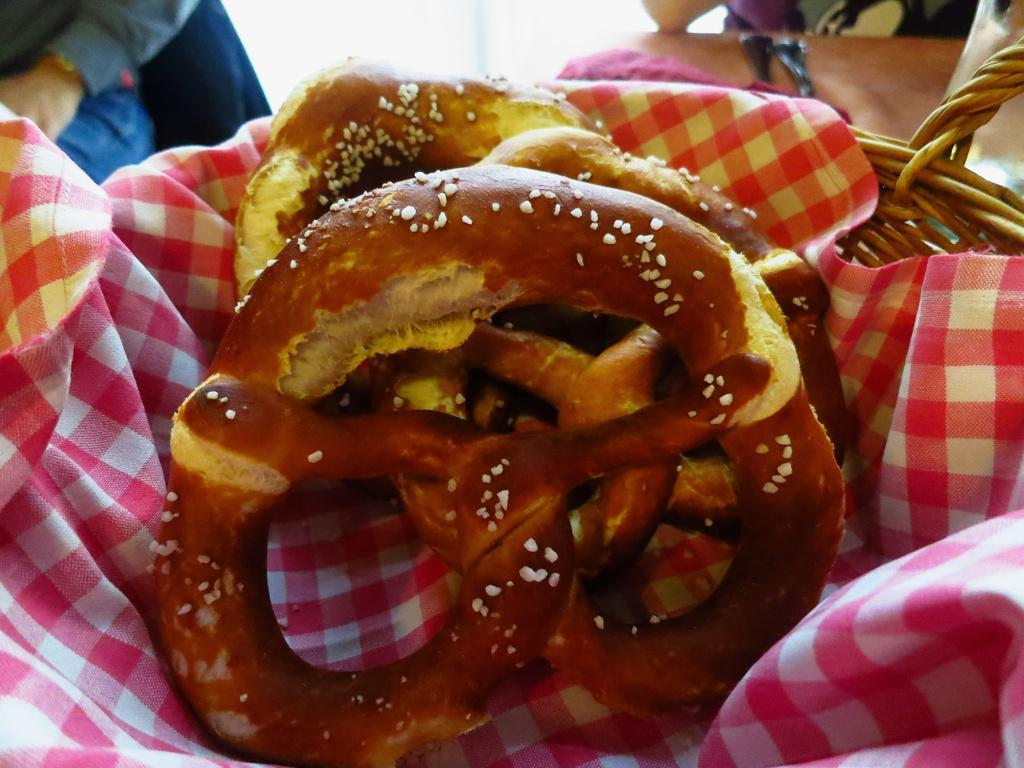Please provide a concise description of this image. In this picture we can see food items, cloth in a basket and in the background we can see two people. 